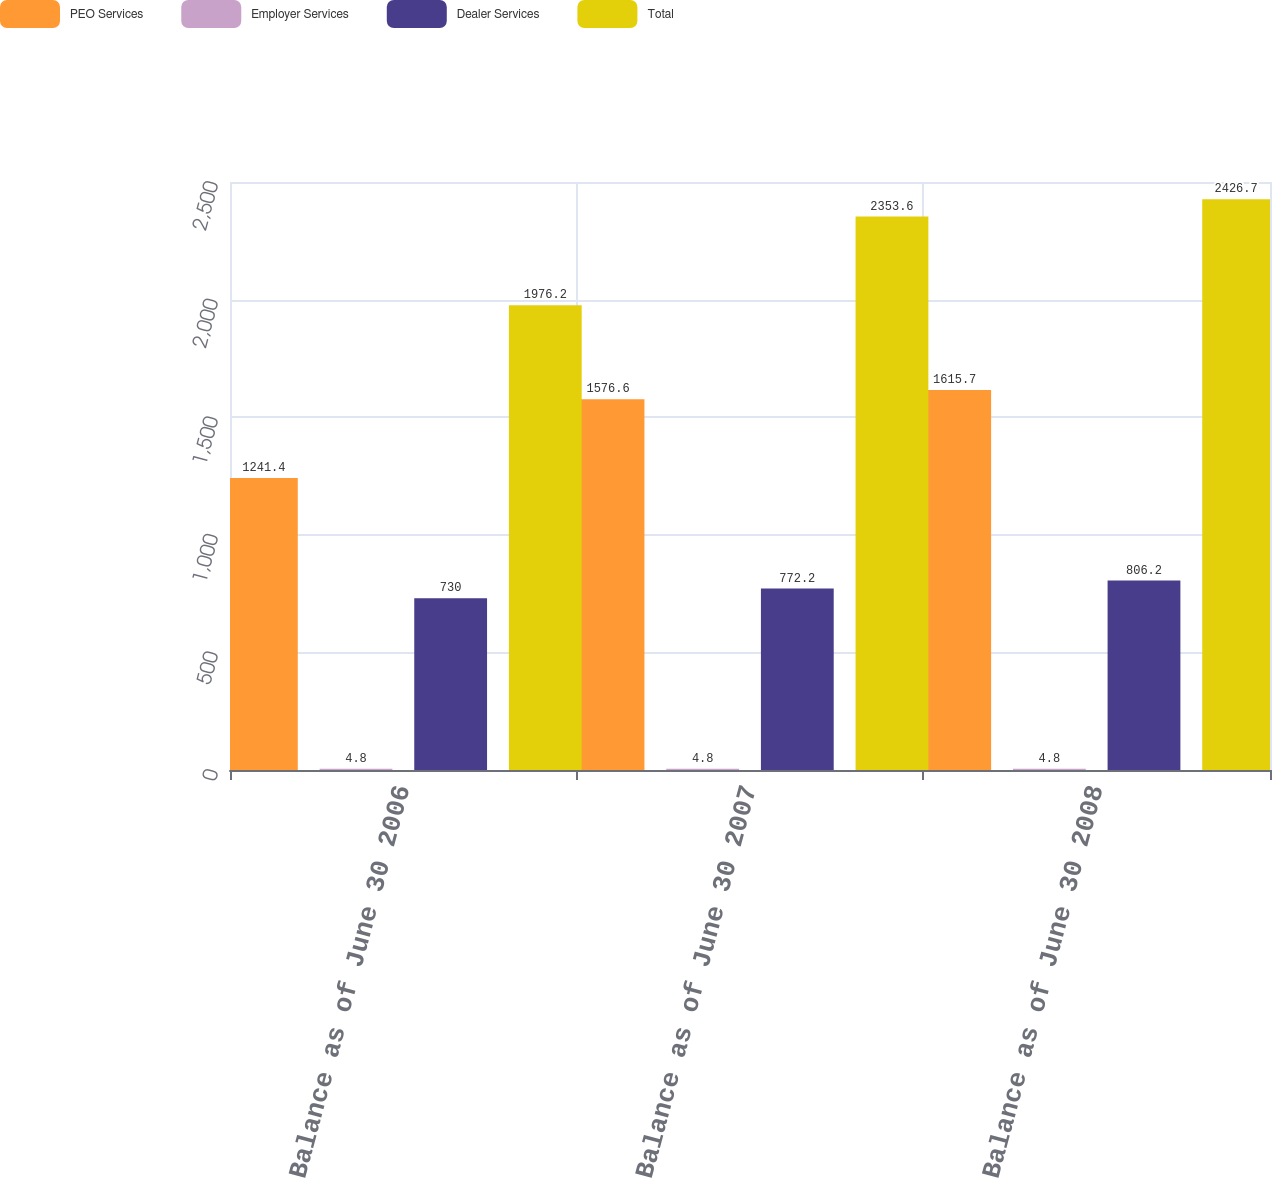<chart> <loc_0><loc_0><loc_500><loc_500><stacked_bar_chart><ecel><fcel>Balance as of June 30 2006<fcel>Balance as of June 30 2007<fcel>Balance as of June 30 2008<nl><fcel>PEO Services<fcel>1241.4<fcel>1576.6<fcel>1615.7<nl><fcel>Employer Services<fcel>4.8<fcel>4.8<fcel>4.8<nl><fcel>Dealer Services<fcel>730<fcel>772.2<fcel>806.2<nl><fcel>Total<fcel>1976.2<fcel>2353.6<fcel>2426.7<nl></chart> 